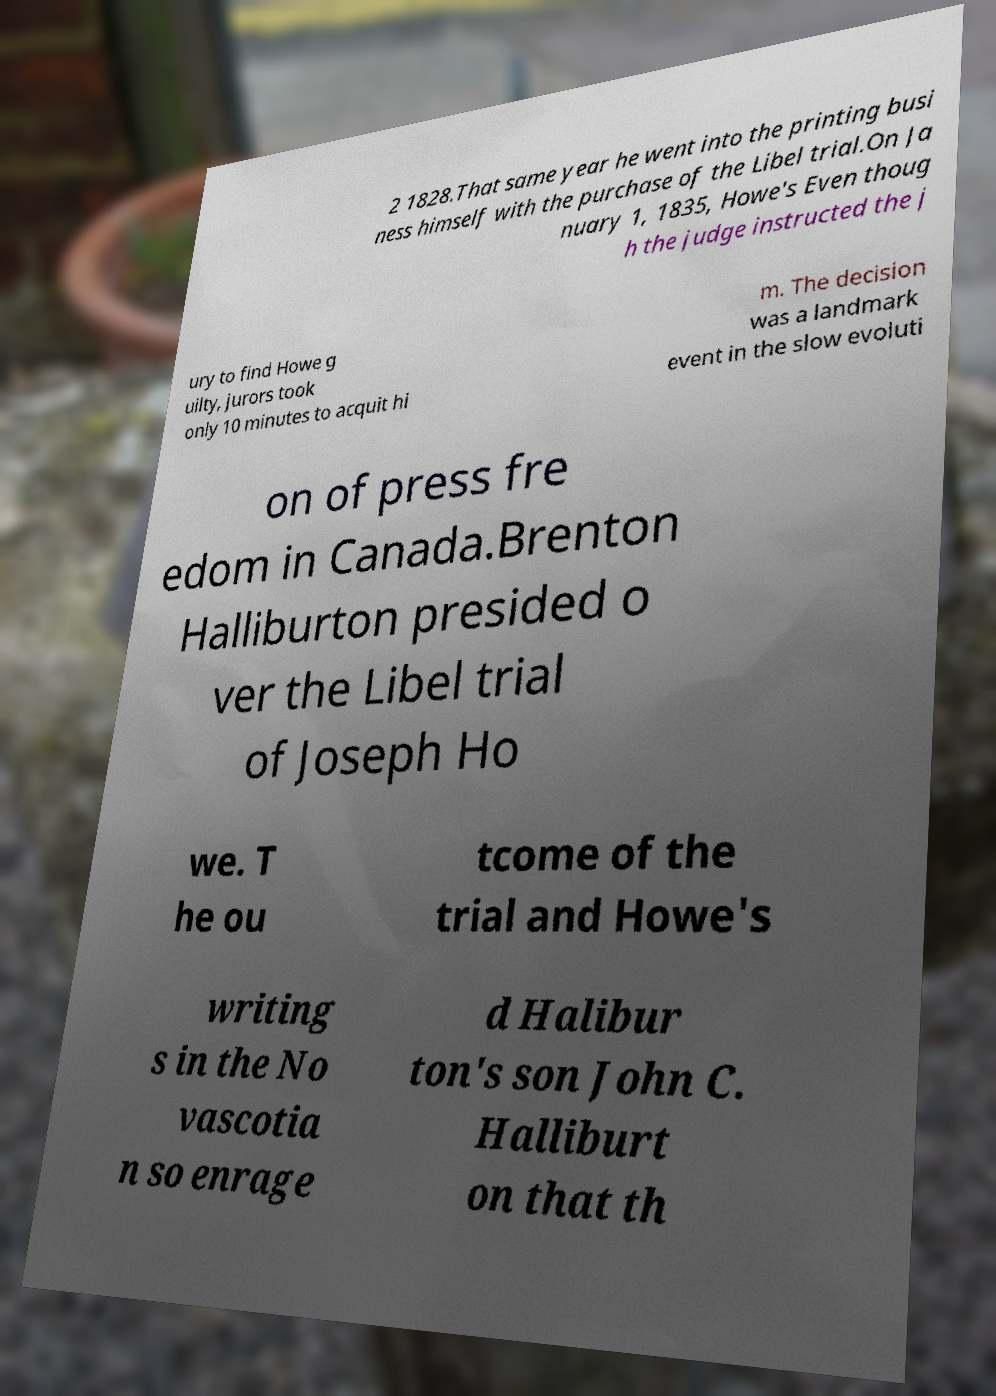Please identify and transcribe the text found in this image. 2 1828.That same year he went into the printing busi ness himself with the purchase of the Libel trial.On Ja nuary 1, 1835, Howe's Even thoug h the judge instructed the j ury to find Howe g uilty, jurors took only 10 minutes to acquit hi m. The decision was a landmark event in the slow evoluti on of press fre edom in Canada.Brenton Halliburton presided o ver the Libel trial of Joseph Ho we. T he ou tcome of the trial and Howe's writing s in the No vascotia n so enrage d Halibur ton's son John C. Halliburt on that th 